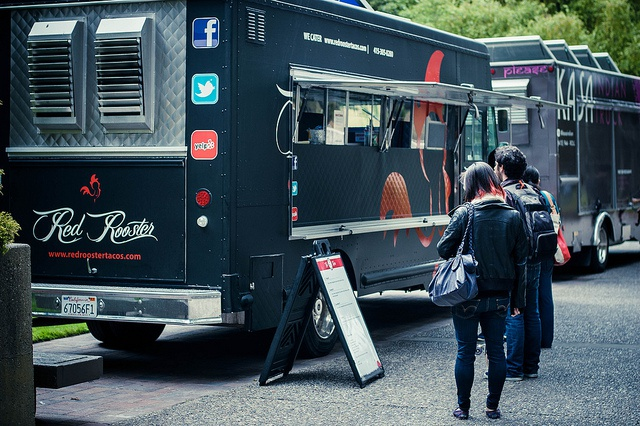Describe the objects in this image and their specific colors. I can see truck in black, darkblue, blue, and lightgray tones, bus in black, gray, and blue tones, truck in black, gray, blue, and navy tones, people in black, navy, blue, and darkgray tones, and people in black, navy, darkgray, and blue tones in this image. 